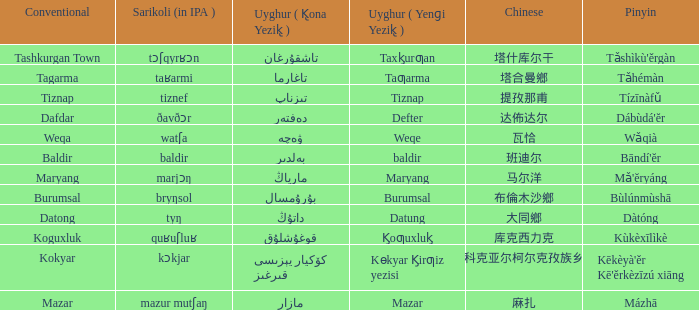Name the pinyin for تىزناپ Tízīnàfǔ. 